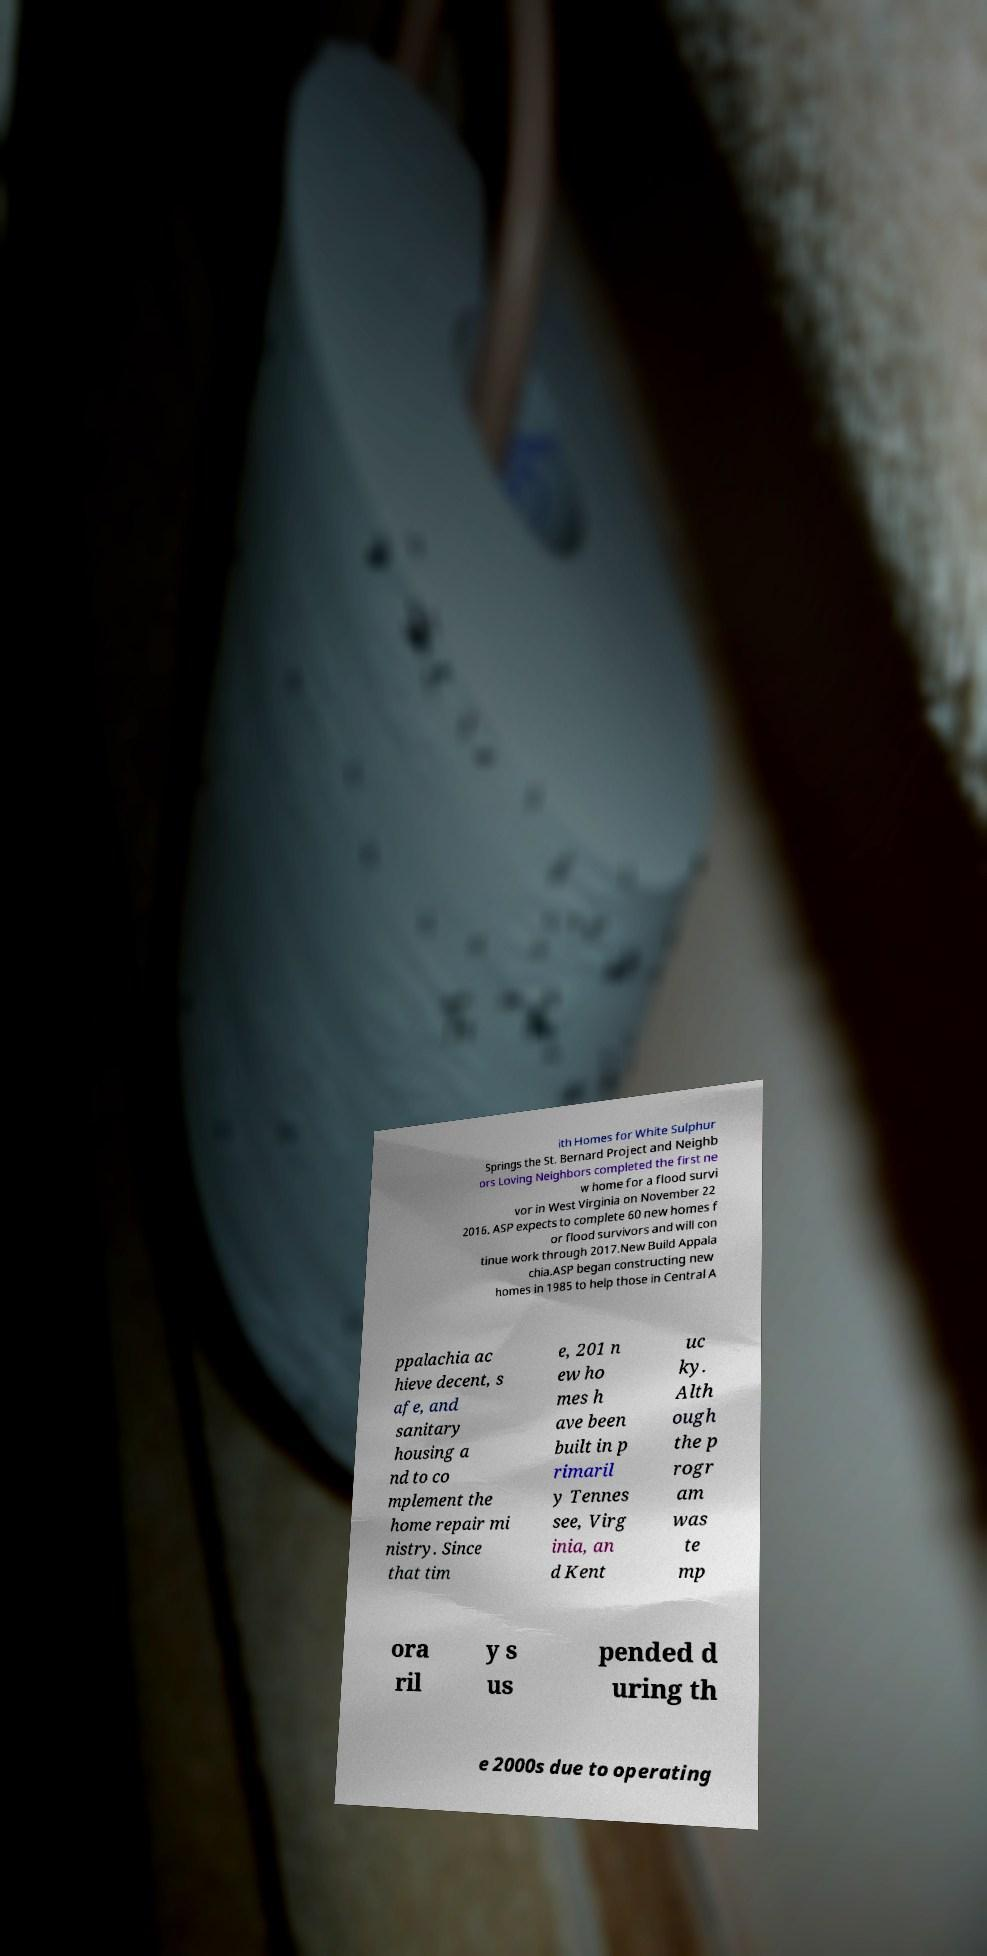Can you accurately transcribe the text from the provided image for me? ith Homes for White Sulphur Springs the St. Bernard Project and Neighb ors Loving Neighbors completed the first ne w home for a flood survi vor in West Virginia on November 22 2016. ASP expects to complete 60 new homes f or flood survivors and will con tinue work through 2017.New Build Appala chia.ASP began constructing new homes in 1985 to help those in Central A ppalachia ac hieve decent, s afe, and sanitary housing a nd to co mplement the home repair mi nistry. Since that tim e, 201 n ew ho mes h ave been built in p rimaril y Tennes see, Virg inia, an d Kent uc ky. Alth ough the p rogr am was te mp ora ril y s us pended d uring th e 2000s due to operating 